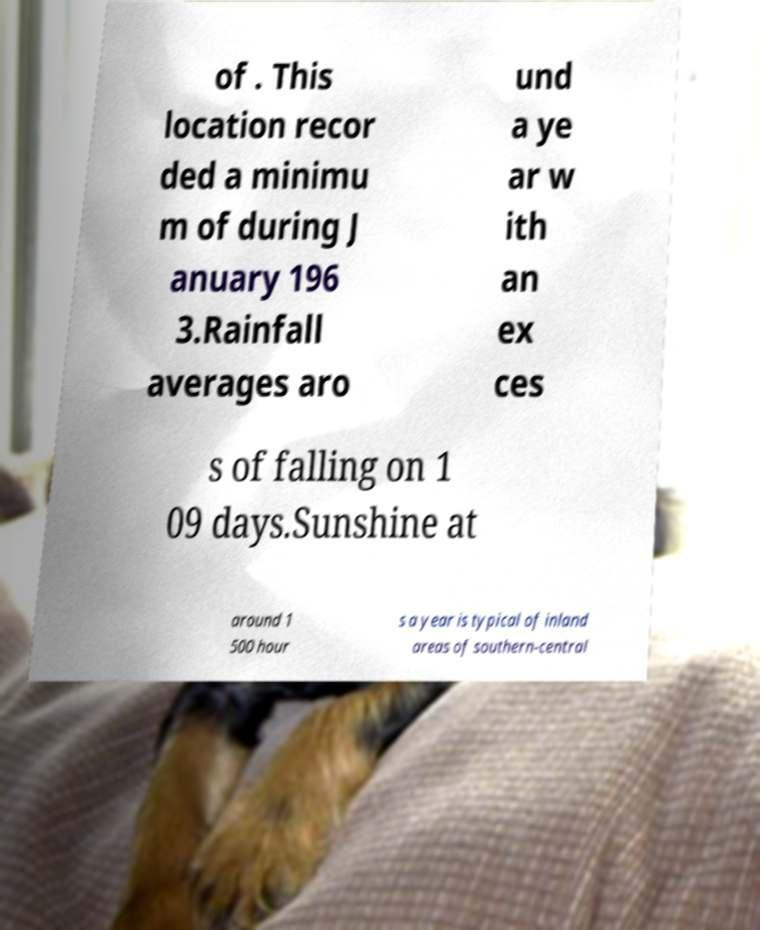Can you accurately transcribe the text from the provided image for me? of . This location recor ded a minimu m of during J anuary 196 3.Rainfall averages aro und a ye ar w ith an ex ces s of falling on 1 09 days.Sunshine at around 1 500 hour s a year is typical of inland areas of southern-central 